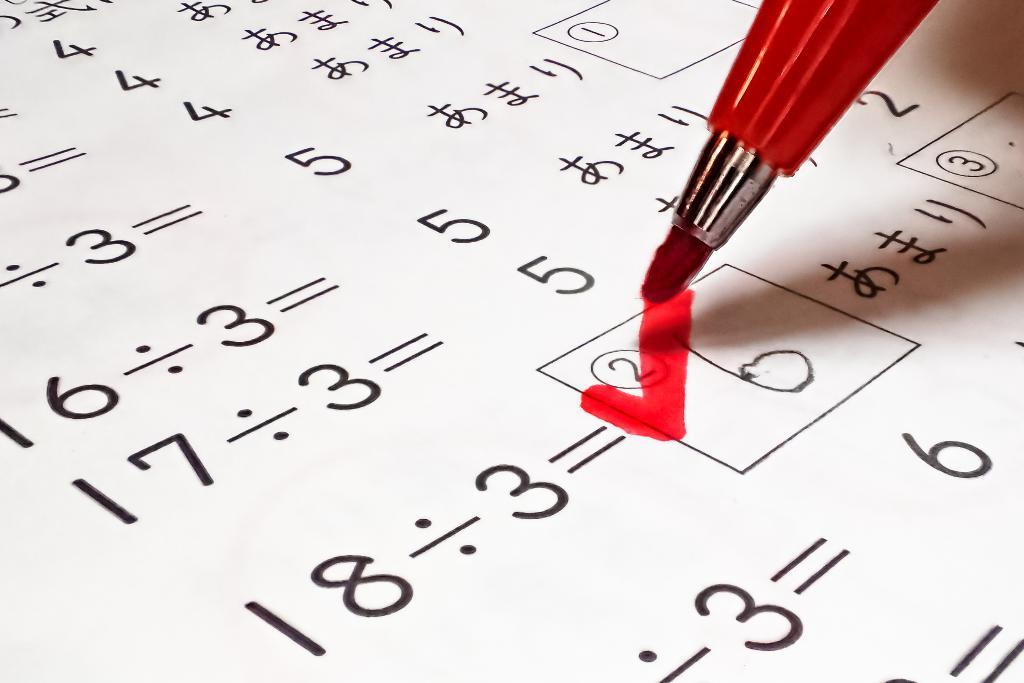What is the color of the marker visible in the image? The marker in the image is red. What is the color of the paper on which something is written? The paper is white. What color is used to write on the white paper? Something is written on the paper with a black color. Can you tell me how many vans are parked near the beggar in the image? There is no van or beggar present in the image. What type of needle is being used to sew the fabric in the image? There is no needle or fabric present in the image. 